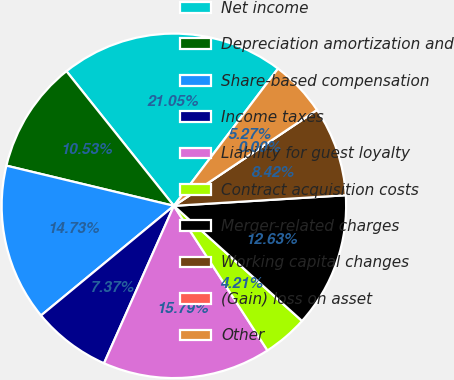<chart> <loc_0><loc_0><loc_500><loc_500><pie_chart><fcel>Net income<fcel>Depreciation amortization and<fcel>Share-based compensation<fcel>Income taxes<fcel>Liability for guest loyalty<fcel>Contract acquisition costs<fcel>Merger-related charges<fcel>Working capital changes<fcel>(Gain) loss on asset<fcel>Other<nl><fcel>21.05%<fcel>10.53%<fcel>14.73%<fcel>7.37%<fcel>15.79%<fcel>4.21%<fcel>12.63%<fcel>8.42%<fcel>0.0%<fcel>5.27%<nl></chart> 